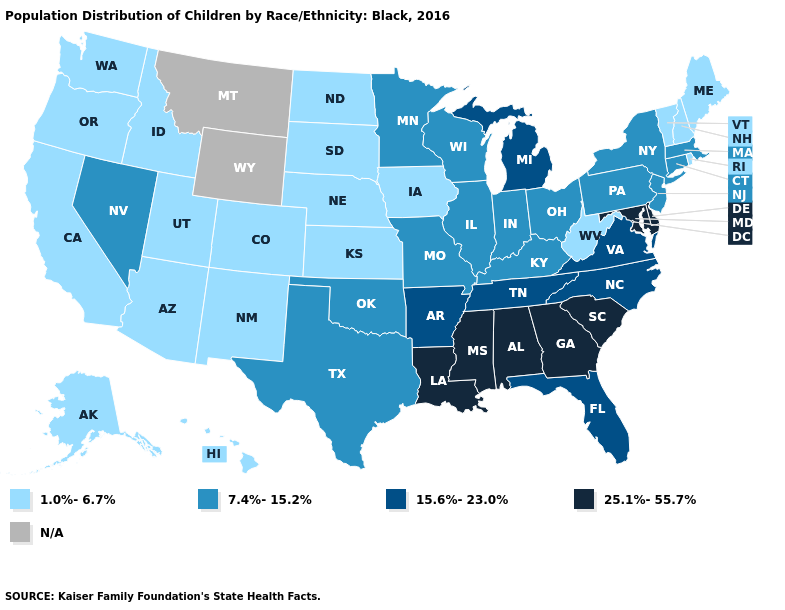Does Pennsylvania have the lowest value in the Northeast?
Concise answer only. No. Does Utah have the lowest value in the West?
Write a very short answer. Yes. What is the value of Montana?
Quick response, please. N/A. Among the states that border Michigan , which have the highest value?
Keep it brief. Indiana, Ohio, Wisconsin. Does Ohio have the lowest value in the USA?
Be succinct. No. What is the value of Indiana?
Write a very short answer. 7.4%-15.2%. Name the states that have a value in the range N/A?
Keep it brief. Montana, Wyoming. What is the value of West Virginia?
Give a very brief answer. 1.0%-6.7%. What is the lowest value in states that border Wyoming?
Quick response, please. 1.0%-6.7%. What is the lowest value in the South?
Keep it brief. 1.0%-6.7%. Among the states that border South Dakota , does Nebraska have the lowest value?
Concise answer only. Yes. What is the lowest value in states that border Nebraska?
Be succinct. 1.0%-6.7%. Does Delaware have the highest value in the USA?
Give a very brief answer. Yes. 